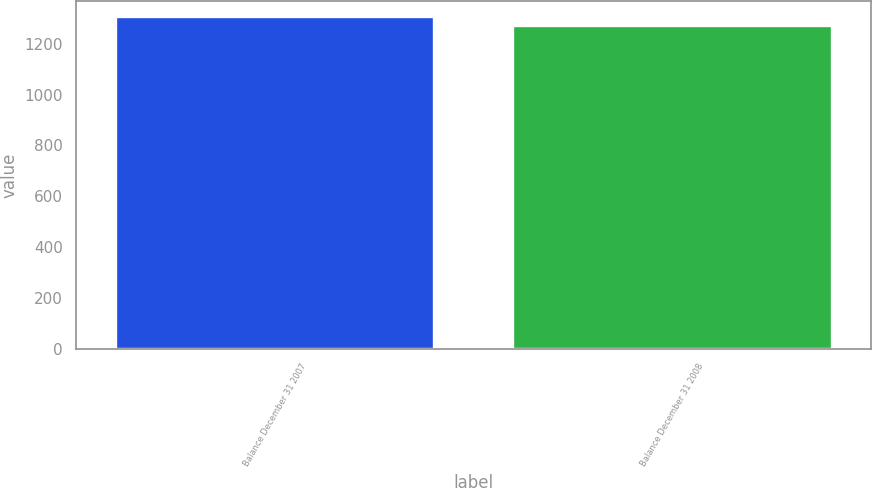Convert chart to OTSL. <chart><loc_0><loc_0><loc_500><loc_500><bar_chart><fcel>Balance December 31 2007<fcel>Balance December 31 2008<nl><fcel>1304<fcel>1270<nl></chart> 